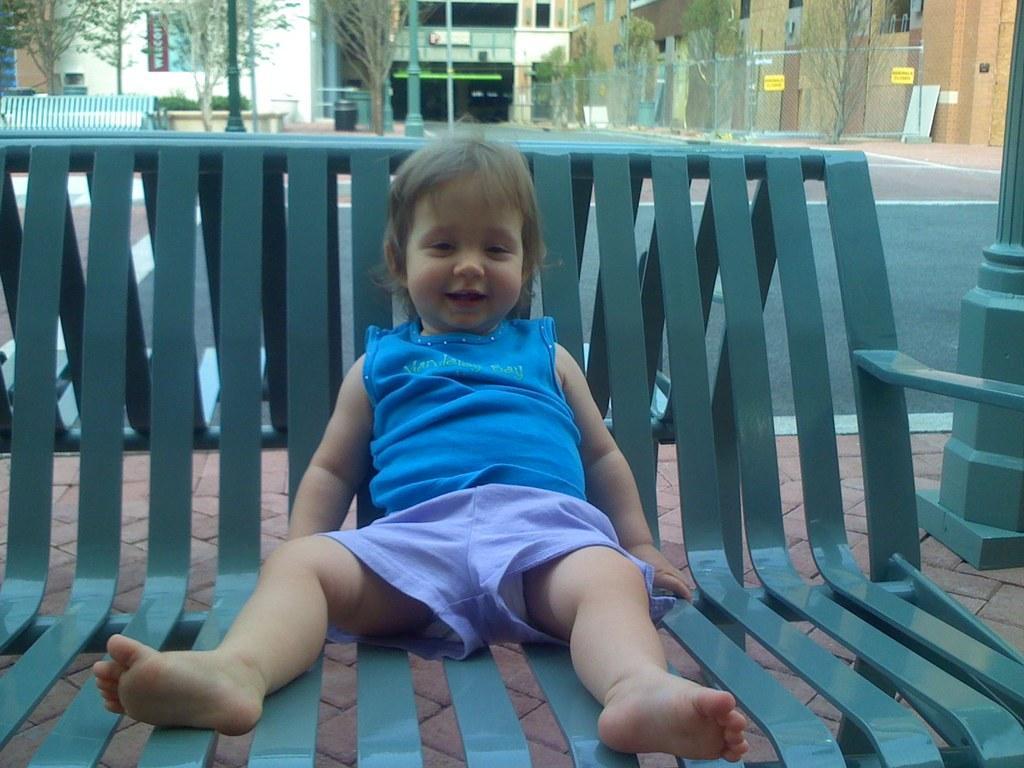Can you describe this image briefly? In the foreground of the picture there is a kid sitting on the bench. On the right there is a pole. In the background that are benches, court, trees, fencing, building, windows, plants and poles. 